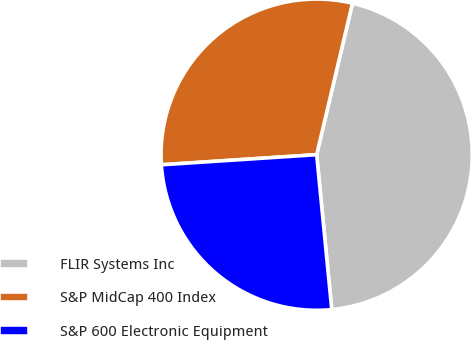Convert chart. <chart><loc_0><loc_0><loc_500><loc_500><pie_chart><fcel>FLIR Systems Inc<fcel>S&P MidCap 400 Index<fcel>S&P 600 Electronic Equipment<nl><fcel>44.76%<fcel>29.73%<fcel>25.51%<nl></chart> 